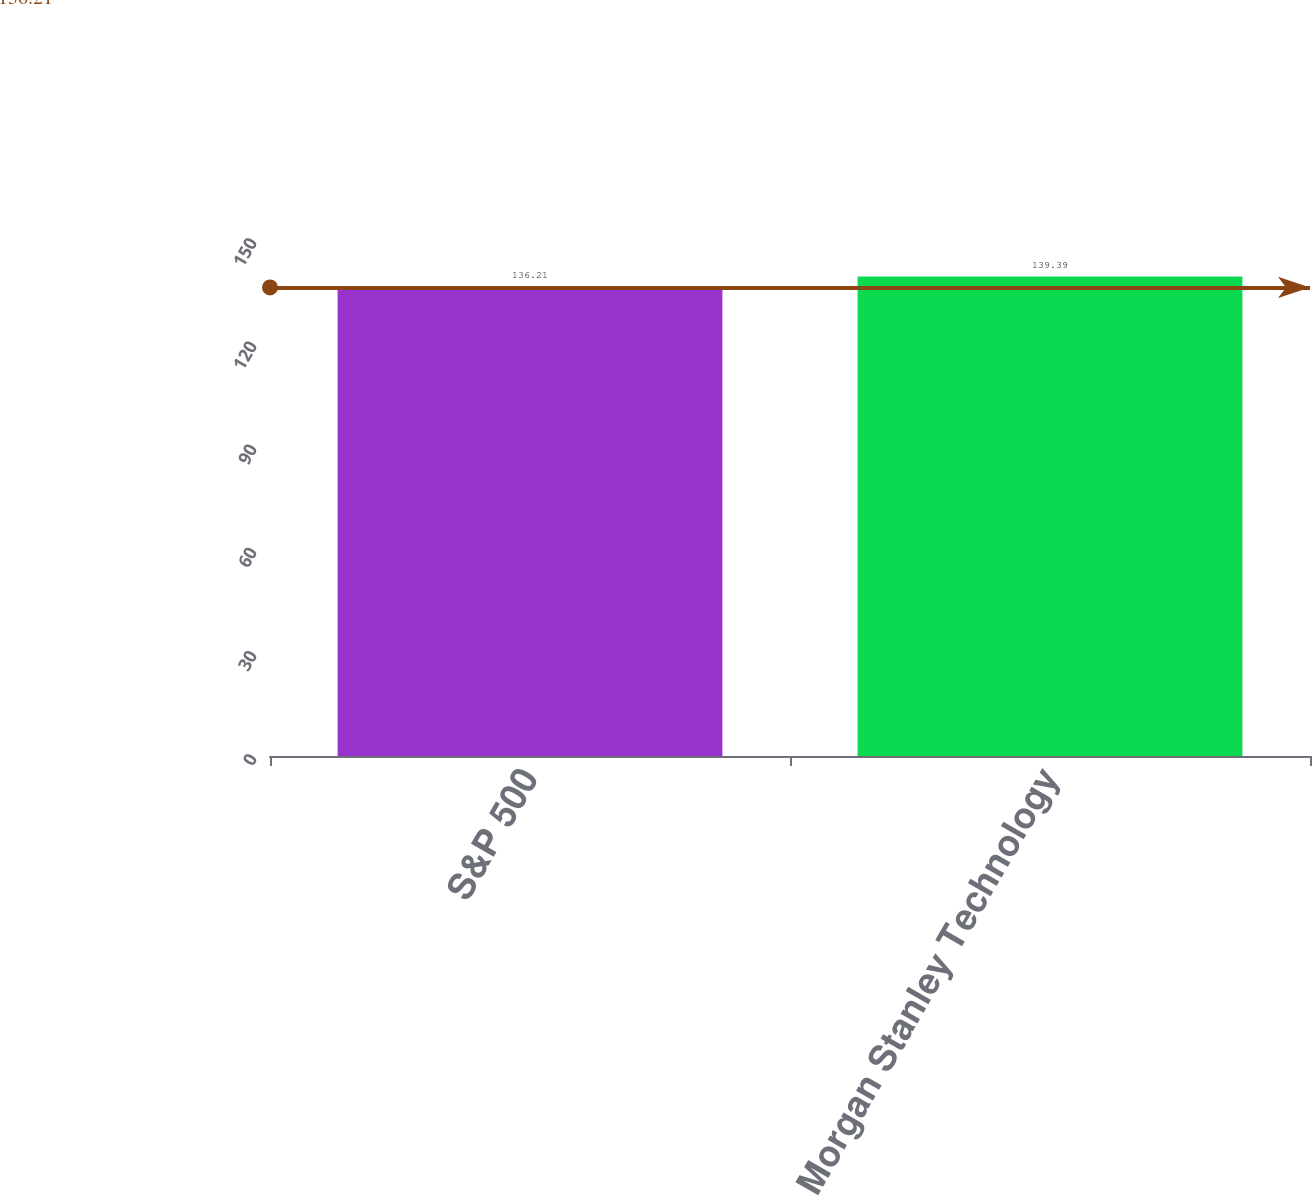Convert chart to OTSL. <chart><loc_0><loc_0><loc_500><loc_500><bar_chart><fcel>S&P 500<fcel>Morgan Stanley Technology<nl><fcel>136.21<fcel>139.39<nl></chart> 